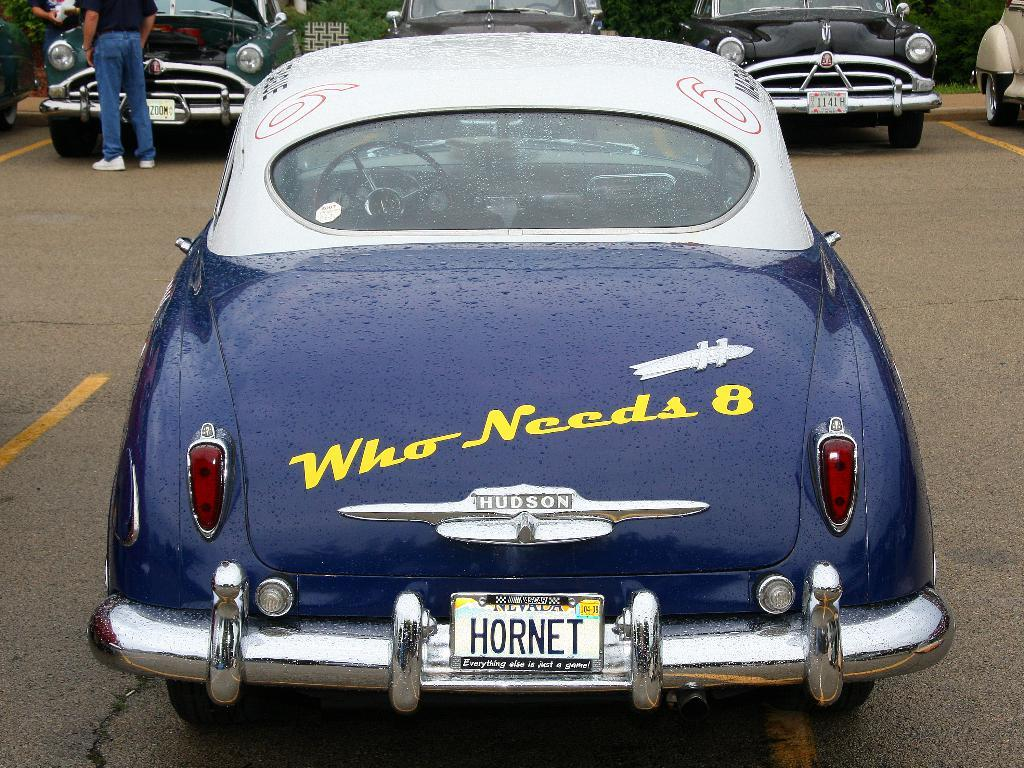What is the main subject on the ground in the image? There is a vehicle on the ground in the image. What can be seen in the background of the image? There are people, other vehicles, and trees visible in the background of the image. Is there a toy steam engine coasting along the shoreline in the image? No, there is no toy steam engine or shoreline present in the image. 